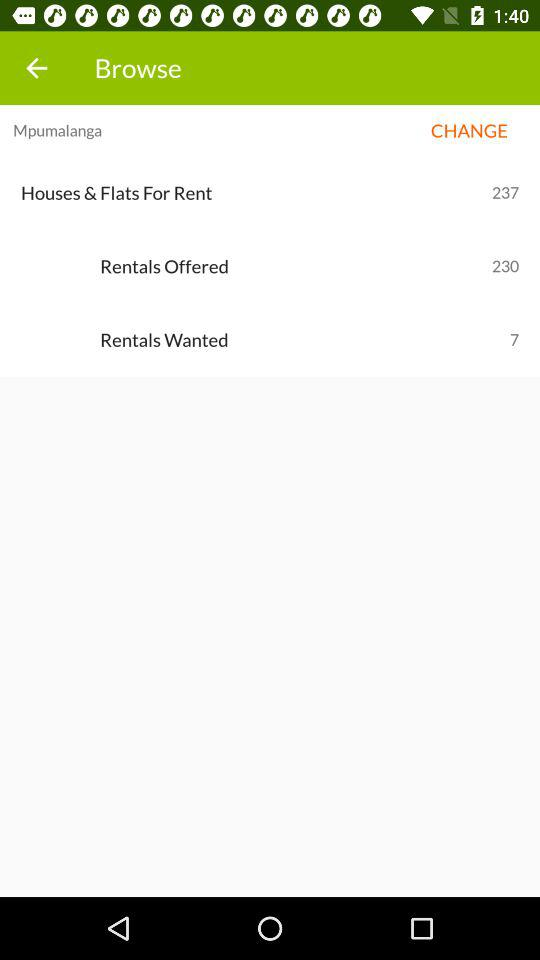How many rentals are offered? There are 230 rentals offered. 